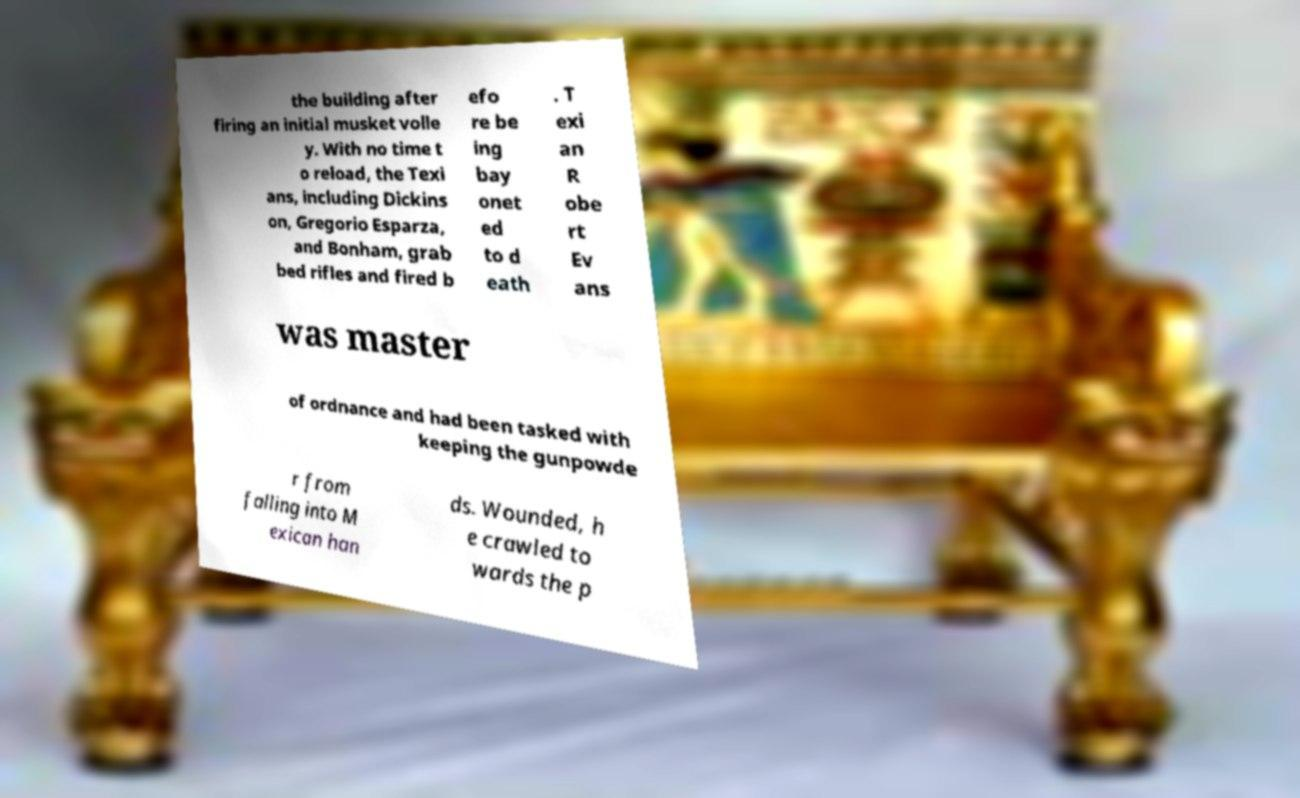What messages or text are displayed in this image? I need them in a readable, typed format. the building after firing an initial musket volle y. With no time t o reload, the Texi ans, including Dickins on, Gregorio Esparza, and Bonham, grab bed rifles and fired b efo re be ing bay onet ed to d eath . T exi an R obe rt Ev ans was master of ordnance and had been tasked with keeping the gunpowde r from falling into M exican han ds. Wounded, h e crawled to wards the p 